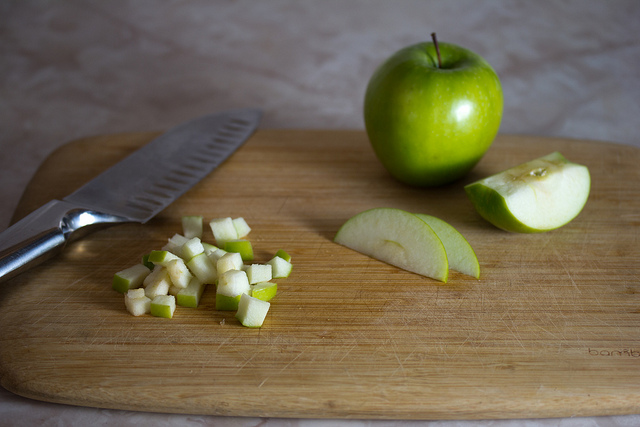What techniques were possibly used to achieve the different cuts of apples seen in the image? The slices likely involved simple knife skills where the apple is held steady and sliced into even wedges. The dicing appears equally meticulous, possibly involving cutting the apple into slices first, then aligning and chopping them into smaller, even cubes, suitable for more delicate or bite-size applications. 